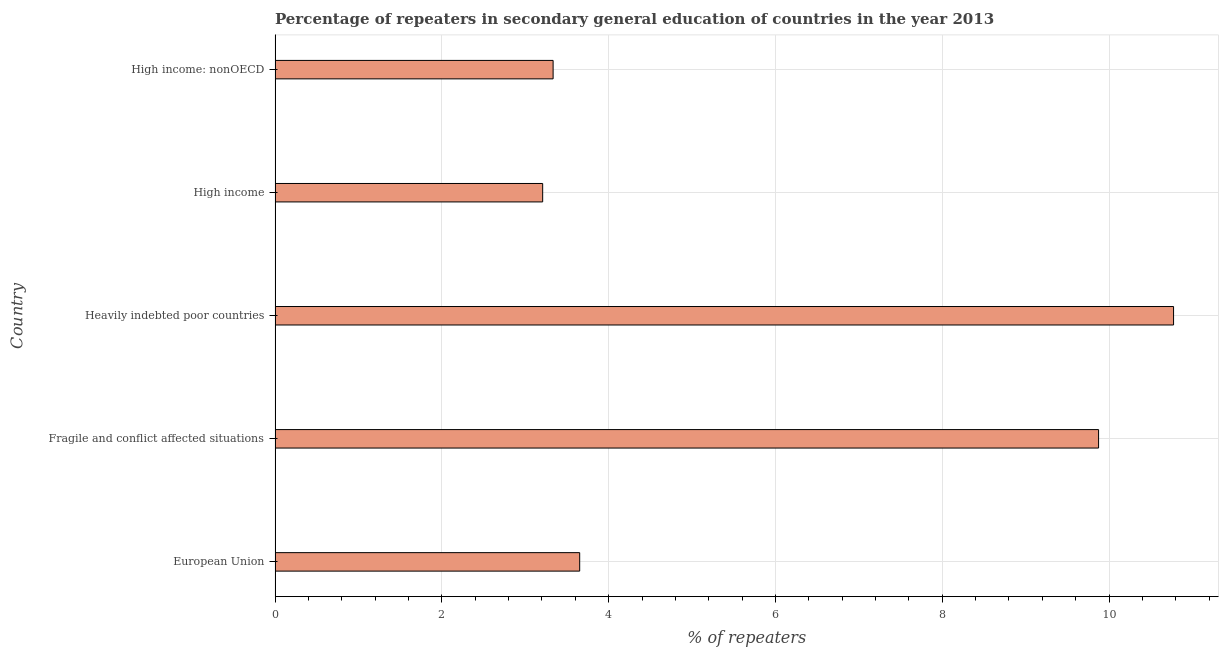Does the graph contain grids?
Your response must be concise. Yes. What is the title of the graph?
Provide a short and direct response. Percentage of repeaters in secondary general education of countries in the year 2013. What is the label or title of the X-axis?
Offer a terse response. % of repeaters. What is the percentage of repeaters in Heavily indebted poor countries?
Give a very brief answer. 10.77. Across all countries, what is the maximum percentage of repeaters?
Your answer should be compact. 10.77. Across all countries, what is the minimum percentage of repeaters?
Provide a succinct answer. 3.21. In which country was the percentage of repeaters maximum?
Your answer should be compact. Heavily indebted poor countries. What is the sum of the percentage of repeaters?
Make the answer very short. 30.84. What is the difference between the percentage of repeaters in Heavily indebted poor countries and High income: nonOECD?
Offer a terse response. 7.44. What is the average percentage of repeaters per country?
Your answer should be compact. 6.17. What is the median percentage of repeaters?
Offer a terse response. 3.65. In how many countries, is the percentage of repeaters greater than 6.4 %?
Your response must be concise. 2. What is the ratio of the percentage of repeaters in European Union to that in Heavily indebted poor countries?
Your response must be concise. 0.34. Is the percentage of repeaters in European Union less than that in Fragile and conflict affected situations?
Your answer should be very brief. Yes. Is the difference between the percentage of repeaters in Fragile and conflict affected situations and High income greater than the difference between any two countries?
Offer a terse response. No. What is the difference between the highest and the second highest percentage of repeaters?
Keep it short and to the point. 0.9. What is the difference between the highest and the lowest percentage of repeaters?
Provide a succinct answer. 7.57. In how many countries, is the percentage of repeaters greater than the average percentage of repeaters taken over all countries?
Your answer should be compact. 2. How many bars are there?
Provide a short and direct response. 5. Are all the bars in the graph horizontal?
Give a very brief answer. Yes. What is the difference between two consecutive major ticks on the X-axis?
Make the answer very short. 2. What is the % of repeaters of European Union?
Provide a succinct answer. 3.65. What is the % of repeaters of Fragile and conflict affected situations?
Your answer should be compact. 9.87. What is the % of repeaters of Heavily indebted poor countries?
Offer a terse response. 10.77. What is the % of repeaters in High income?
Make the answer very short. 3.21. What is the % of repeaters of High income: nonOECD?
Ensure brevity in your answer.  3.33. What is the difference between the % of repeaters in European Union and Fragile and conflict affected situations?
Provide a short and direct response. -6.22. What is the difference between the % of repeaters in European Union and Heavily indebted poor countries?
Provide a short and direct response. -7.12. What is the difference between the % of repeaters in European Union and High income?
Provide a short and direct response. 0.44. What is the difference between the % of repeaters in European Union and High income: nonOECD?
Offer a very short reply. 0.32. What is the difference between the % of repeaters in Fragile and conflict affected situations and Heavily indebted poor countries?
Your answer should be compact. -0.9. What is the difference between the % of repeaters in Fragile and conflict affected situations and High income?
Ensure brevity in your answer.  6.67. What is the difference between the % of repeaters in Fragile and conflict affected situations and High income: nonOECD?
Your response must be concise. 6.54. What is the difference between the % of repeaters in Heavily indebted poor countries and High income?
Your response must be concise. 7.57. What is the difference between the % of repeaters in Heavily indebted poor countries and High income: nonOECD?
Give a very brief answer. 7.44. What is the difference between the % of repeaters in High income and High income: nonOECD?
Offer a terse response. -0.13. What is the ratio of the % of repeaters in European Union to that in Fragile and conflict affected situations?
Your answer should be compact. 0.37. What is the ratio of the % of repeaters in European Union to that in Heavily indebted poor countries?
Keep it short and to the point. 0.34. What is the ratio of the % of repeaters in European Union to that in High income?
Your response must be concise. 1.14. What is the ratio of the % of repeaters in European Union to that in High income: nonOECD?
Your answer should be compact. 1.1. What is the ratio of the % of repeaters in Fragile and conflict affected situations to that in Heavily indebted poor countries?
Provide a succinct answer. 0.92. What is the ratio of the % of repeaters in Fragile and conflict affected situations to that in High income?
Keep it short and to the point. 3.08. What is the ratio of the % of repeaters in Fragile and conflict affected situations to that in High income: nonOECD?
Keep it short and to the point. 2.96. What is the ratio of the % of repeaters in Heavily indebted poor countries to that in High income?
Your answer should be very brief. 3.36. What is the ratio of the % of repeaters in Heavily indebted poor countries to that in High income: nonOECD?
Give a very brief answer. 3.23. 